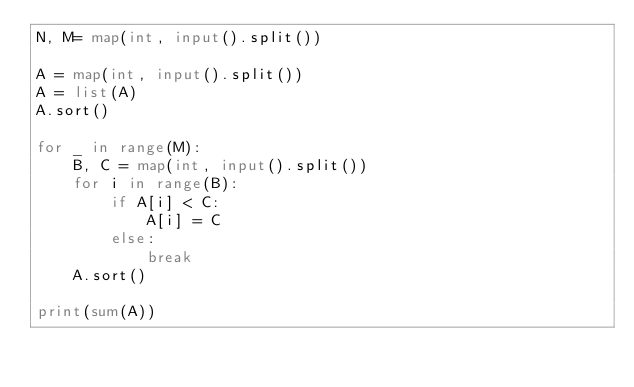<code> <loc_0><loc_0><loc_500><loc_500><_Python_>N, M= map(int, input().split())

A = map(int, input().split())
A = list(A)
A.sort()

for _ in range(M):
    B, C = map(int, input().split())
    for i in range(B):
        if A[i] < C:
            A[i] = C
        else:
            break
    A.sort()

print(sum(A))
</code> 